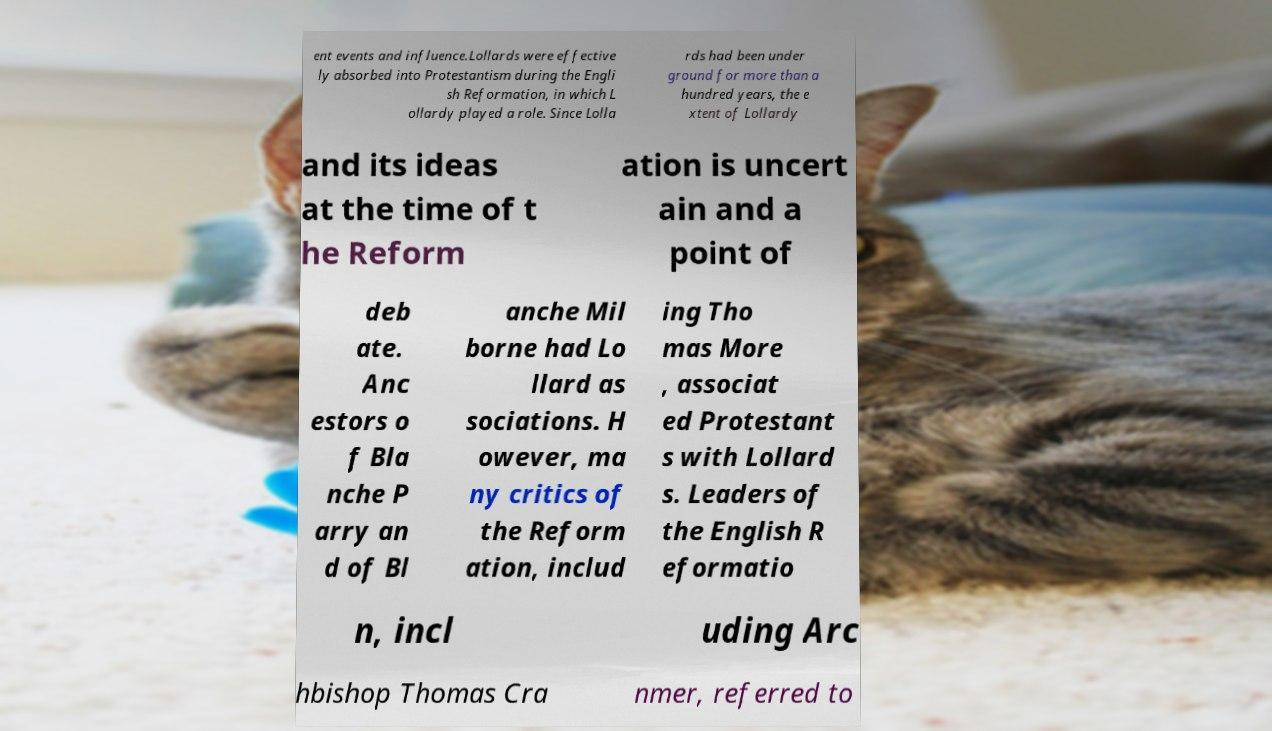Please read and relay the text visible in this image. What does it say? ent events and influence.Lollards were effective ly absorbed into Protestantism during the Engli sh Reformation, in which L ollardy played a role. Since Lolla rds had been under ground for more than a hundred years, the e xtent of Lollardy and its ideas at the time of t he Reform ation is uncert ain and a point of deb ate. Anc estors o f Bla nche P arry an d of Bl anche Mil borne had Lo llard as sociations. H owever, ma ny critics of the Reform ation, includ ing Tho mas More , associat ed Protestant s with Lollard s. Leaders of the English R eformatio n, incl uding Arc hbishop Thomas Cra nmer, referred to 